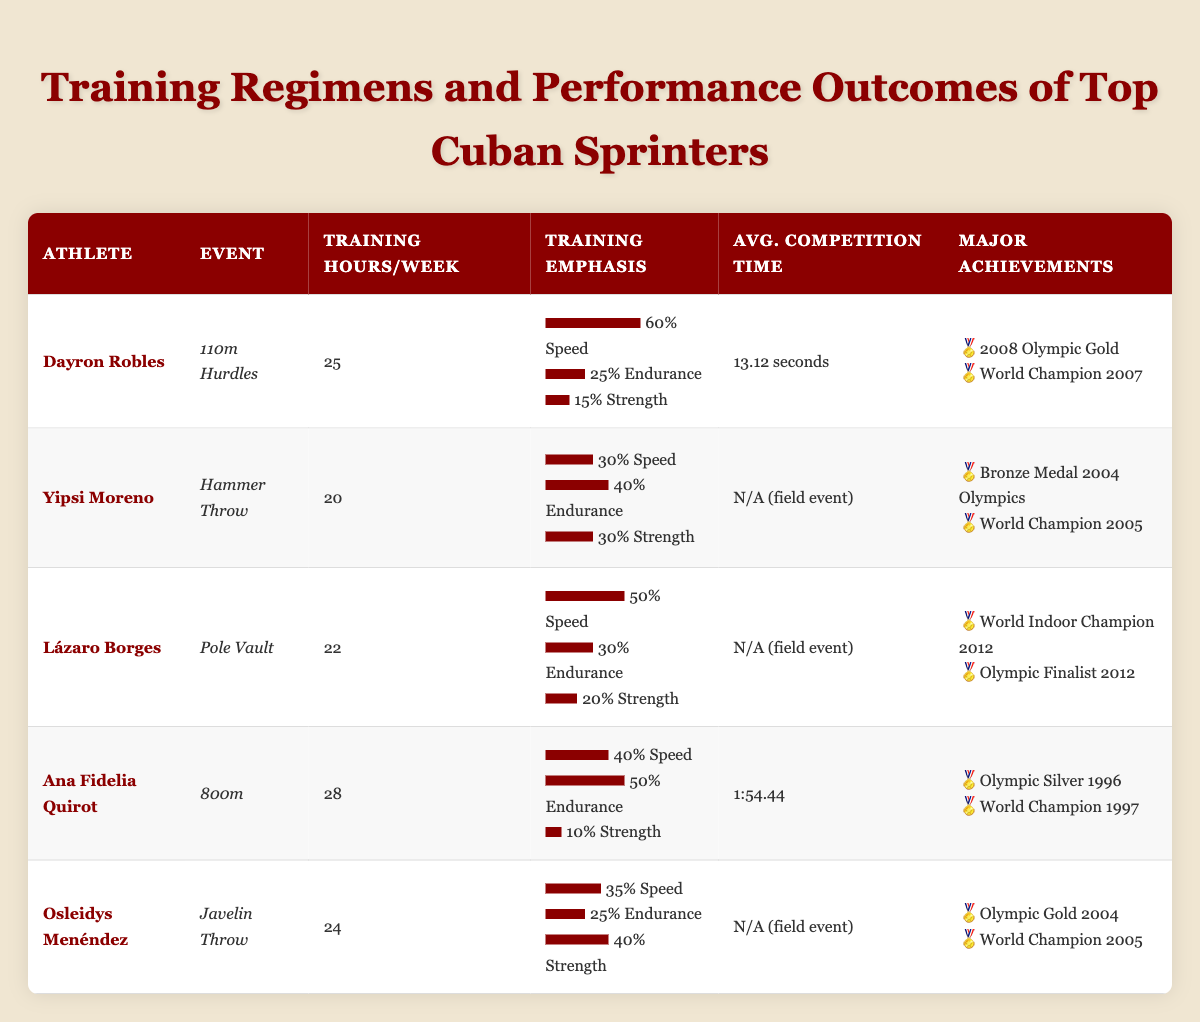What is the average training hours per week for the athletes? To find the average training hours, we sum the training hours: 25 + 20 + 22 + 28 + 24 = 119. Then we divide by the number of athletes (5) to get the average: 119 / 5 = 23.8.
Answer: 23.8 Which athlete has the highest speed work emphasis? By examining the table, we see that Dayron Robles has the highest speed work emphasis at 60%.
Answer: Dayron Robles Is Ana Fidelia Quirot's average competition time faster than 2 minutes? Ana Fidelia Quirot's average time is listed as 1:54.44, which is less than 2 minutes.
Answer: Yes How many athletes emphasize endurance work more than 40% in their training? A count of the athletes shows Ana Fidelia Quirot (50%) and Yipsi Moreno (40%), which makes a total of 2 athletes emphasizing endurance work above 40%.
Answer: 2 What is the difference in training hours between the athlete with the most and the least training hours? The athlete with the most training hours is Ana Fidelia Quirot (28 hours) and the one with the least is Yipsi Moreno (20 hours), thus the difference is 28 - 20 = 8 hours.
Answer: 8 hours Does any athlete specialize in both speed and strength work with an emphasis over 30%? Checking the table shows that both Yipsi Moreno (30% speed) and Osleidys Menéndez (35% speed) have speed emphasis equal to or above 30%, but their strength emphasis is above 30% only for Osleidys Menéndez (40% strength). Therefore, Osleidys Menéndez fits this criterion.
Answer: Yes Which athlete has participated in the Olympics? Looking through the major achievements, Dayron Robles, Ana Fidelia Quirot, and Osleidys Menéndez are noted to have participated in the Olympics.
Answer: Dayron Robles, Ana Fidelia Quirot, Osleidys Menéndez What percentage of Lázaro Borges's training is dedicated to endurance work? The table states that Lázaro Borges has an endurance work emphasis of 30%.
Answer: 30% Which athlete has both Olympic and World Champion titles? By reviewing the achievements listed, Osleidys Menéndez has both Olympic Gold (2004) and a World Champion title (2005).
Answer: Osleidys Menéndez 